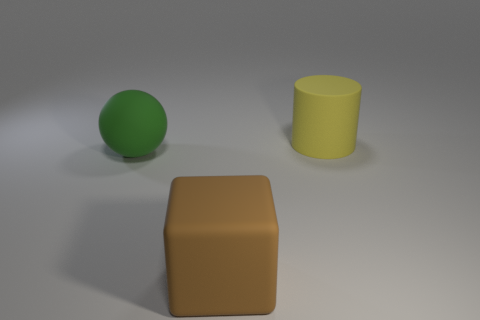Are there any cylinders that have the same material as the green thing?
Offer a terse response. Yes. There is a rubber object on the right side of the brown thing; is its size the same as the rubber cube?
Give a very brief answer. Yes. How many purple things are either large metallic cubes or large matte objects?
Your response must be concise. 0. What material is the large object behind the ball?
Ensure brevity in your answer.  Rubber. There is a large object in front of the big green thing; what number of big brown objects are on the right side of it?
Your answer should be very brief. 0. How many other green matte things have the same shape as the green rubber thing?
Provide a short and direct response. 0. How many big brown matte things are there?
Your answer should be very brief. 1. There is a big rubber object to the right of the brown matte object; what is its color?
Make the answer very short. Yellow. There is a large thing that is to the left of the rubber thing in front of the matte sphere; what is its color?
Your answer should be compact. Green. What color is the sphere that is the same size as the yellow thing?
Make the answer very short. Green. 